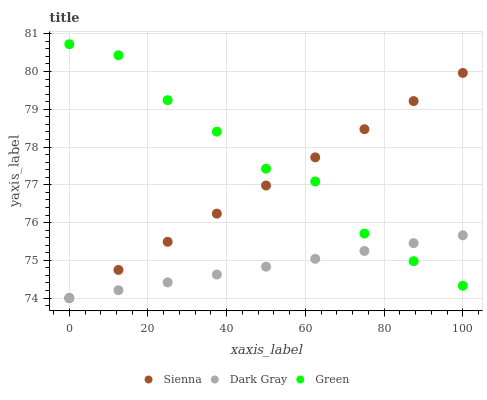Does Dark Gray have the minimum area under the curve?
Answer yes or no. Yes. Does Green have the maximum area under the curve?
Answer yes or no. Yes. Does Green have the minimum area under the curve?
Answer yes or no. No. Does Dark Gray have the maximum area under the curve?
Answer yes or no. No. Is Sienna the smoothest?
Answer yes or no. Yes. Is Green the roughest?
Answer yes or no. Yes. Is Dark Gray the smoothest?
Answer yes or no. No. Is Dark Gray the roughest?
Answer yes or no. No. Does Sienna have the lowest value?
Answer yes or no. Yes. Does Green have the lowest value?
Answer yes or no. No. Does Green have the highest value?
Answer yes or no. Yes. Does Dark Gray have the highest value?
Answer yes or no. No. Does Green intersect Sienna?
Answer yes or no. Yes. Is Green less than Sienna?
Answer yes or no. No. Is Green greater than Sienna?
Answer yes or no. No. 